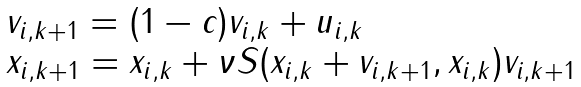<formula> <loc_0><loc_0><loc_500><loc_500>\begin{array} { l } v _ { i , k + 1 } = ( 1 - c ) v _ { i , k } + u _ { i , k } \\ x _ { i , k + 1 } = x _ { i , k } + \nu S ( x _ { i , k } + v _ { i , k + 1 } , x _ { i , k } ) v _ { i , k + 1 } \end{array}</formula> 